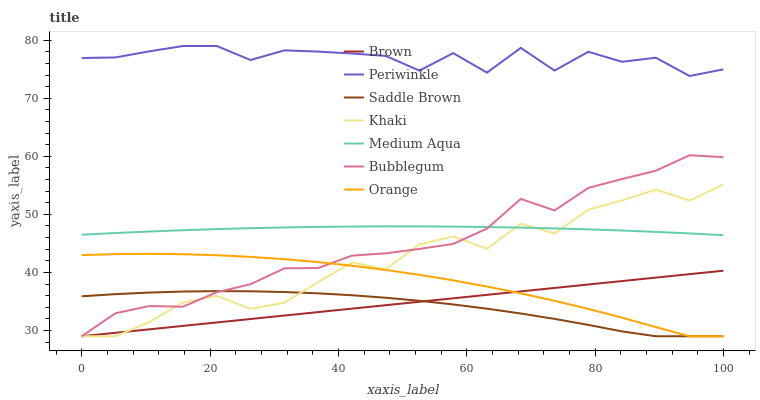Does Saddle Brown have the minimum area under the curve?
Answer yes or no. Yes. Does Periwinkle have the maximum area under the curve?
Answer yes or no. Yes. Does Khaki have the minimum area under the curve?
Answer yes or no. No. Does Khaki have the maximum area under the curve?
Answer yes or no. No. Is Brown the smoothest?
Answer yes or no. Yes. Is Periwinkle the roughest?
Answer yes or no. Yes. Is Khaki the smoothest?
Answer yes or no. No. Is Khaki the roughest?
Answer yes or no. No. Does Brown have the lowest value?
Answer yes or no. Yes. Does Medium Aqua have the lowest value?
Answer yes or no. No. Does Periwinkle have the highest value?
Answer yes or no. Yes. Does Khaki have the highest value?
Answer yes or no. No. Is Brown less than Periwinkle?
Answer yes or no. Yes. Is Periwinkle greater than Saddle Brown?
Answer yes or no. Yes. Does Saddle Brown intersect Brown?
Answer yes or no. Yes. Is Saddle Brown less than Brown?
Answer yes or no. No. Is Saddle Brown greater than Brown?
Answer yes or no. No. Does Brown intersect Periwinkle?
Answer yes or no. No. 